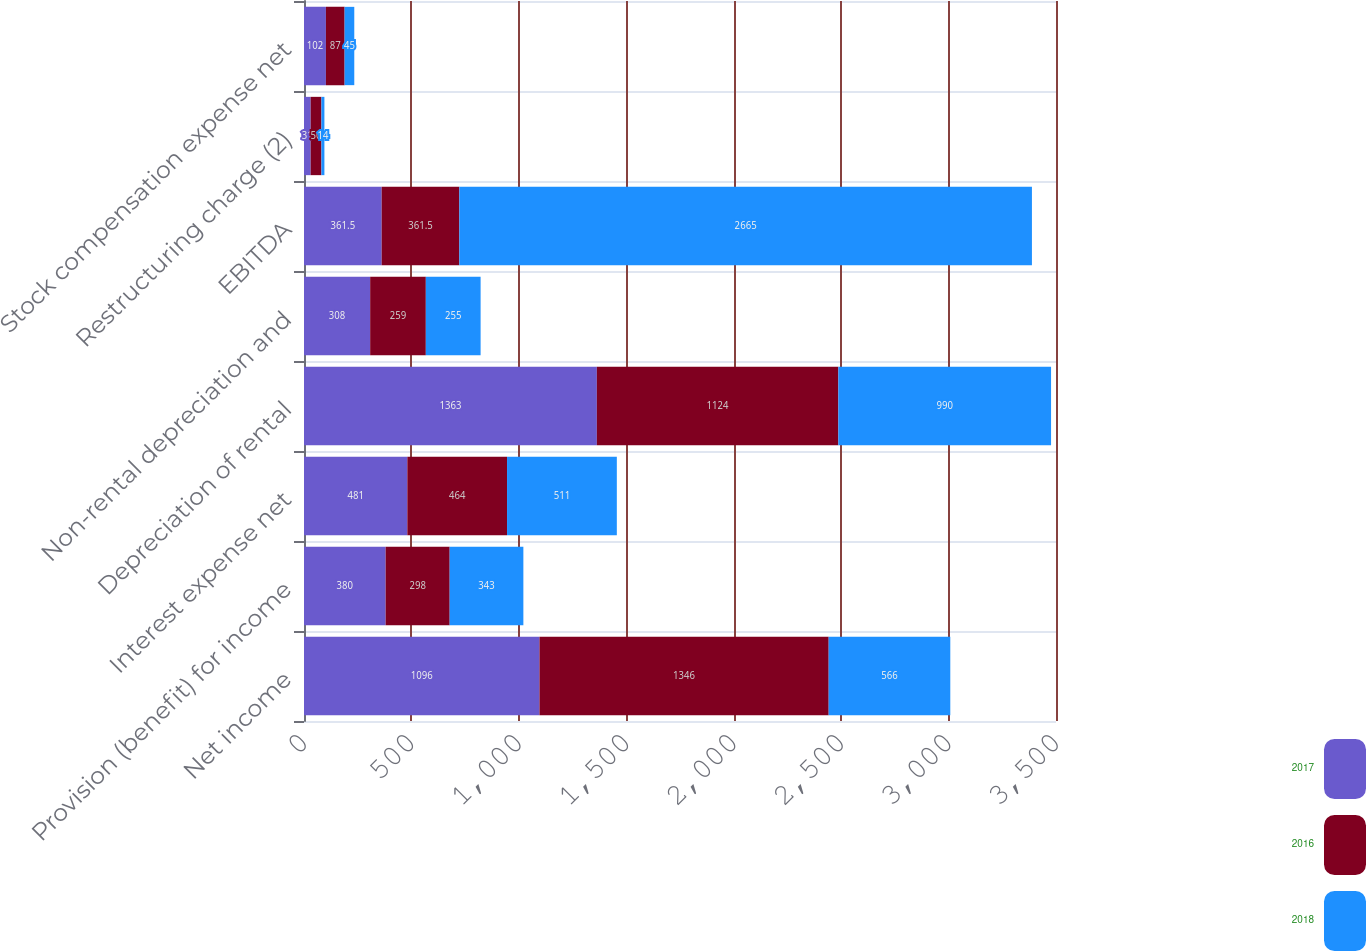<chart> <loc_0><loc_0><loc_500><loc_500><stacked_bar_chart><ecel><fcel>Net income<fcel>Provision (benefit) for income<fcel>Interest expense net<fcel>Depreciation of rental<fcel>Non-rental depreciation and<fcel>EBITDA<fcel>Restructuring charge (2)<fcel>Stock compensation expense net<nl><fcel>2017<fcel>1096<fcel>380<fcel>481<fcel>1363<fcel>308<fcel>361.5<fcel>31<fcel>102<nl><fcel>2016<fcel>1346<fcel>298<fcel>464<fcel>1124<fcel>259<fcel>361.5<fcel>50<fcel>87<nl><fcel>2018<fcel>566<fcel>343<fcel>511<fcel>990<fcel>255<fcel>2665<fcel>14<fcel>45<nl></chart> 